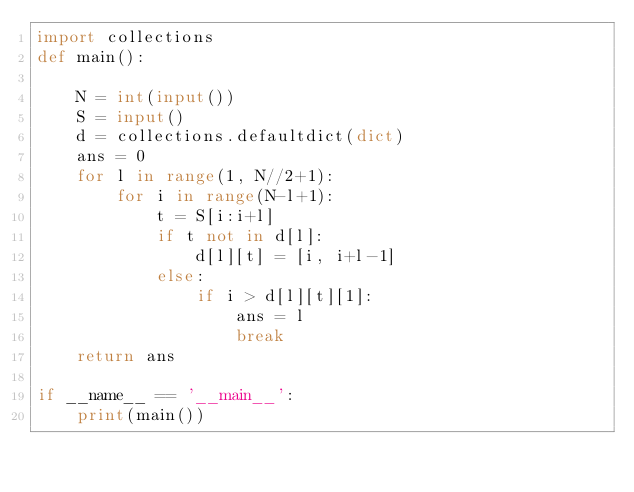<code> <loc_0><loc_0><loc_500><loc_500><_Python_>import collections
def main():

    N = int(input())
    S = input()
    d = collections.defaultdict(dict)
    ans = 0
    for l in range(1, N//2+1):
        for i in range(N-l+1):
            t = S[i:i+l]
            if t not in d[l]:
                d[l][t] = [i, i+l-1]
            else:
                if i > d[l][t][1]:
                    ans = l
                    break
    return ans

if __name__ == '__main__':
    print(main())</code> 